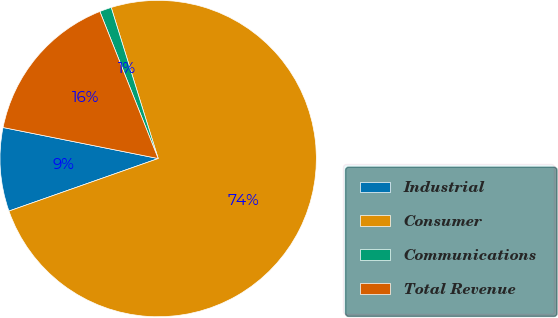Convert chart. <chart><loc_0><loc_0><loc_500><loc_500><pie_chart><fcel>Industrial<fcel>Consumer<fcel>Communications<fcel>Total Revenue<nl><fcel>8.53%<fcel>74.41%<fcel>1.21%<fcel>15.85%<nl></chart> 